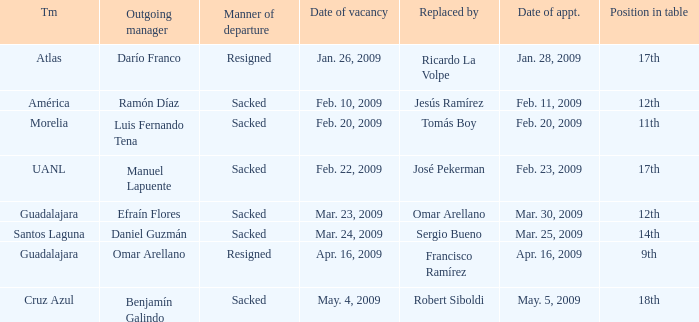What is Position in Table, when Replaced by is "José Pekerman"? 17th. 